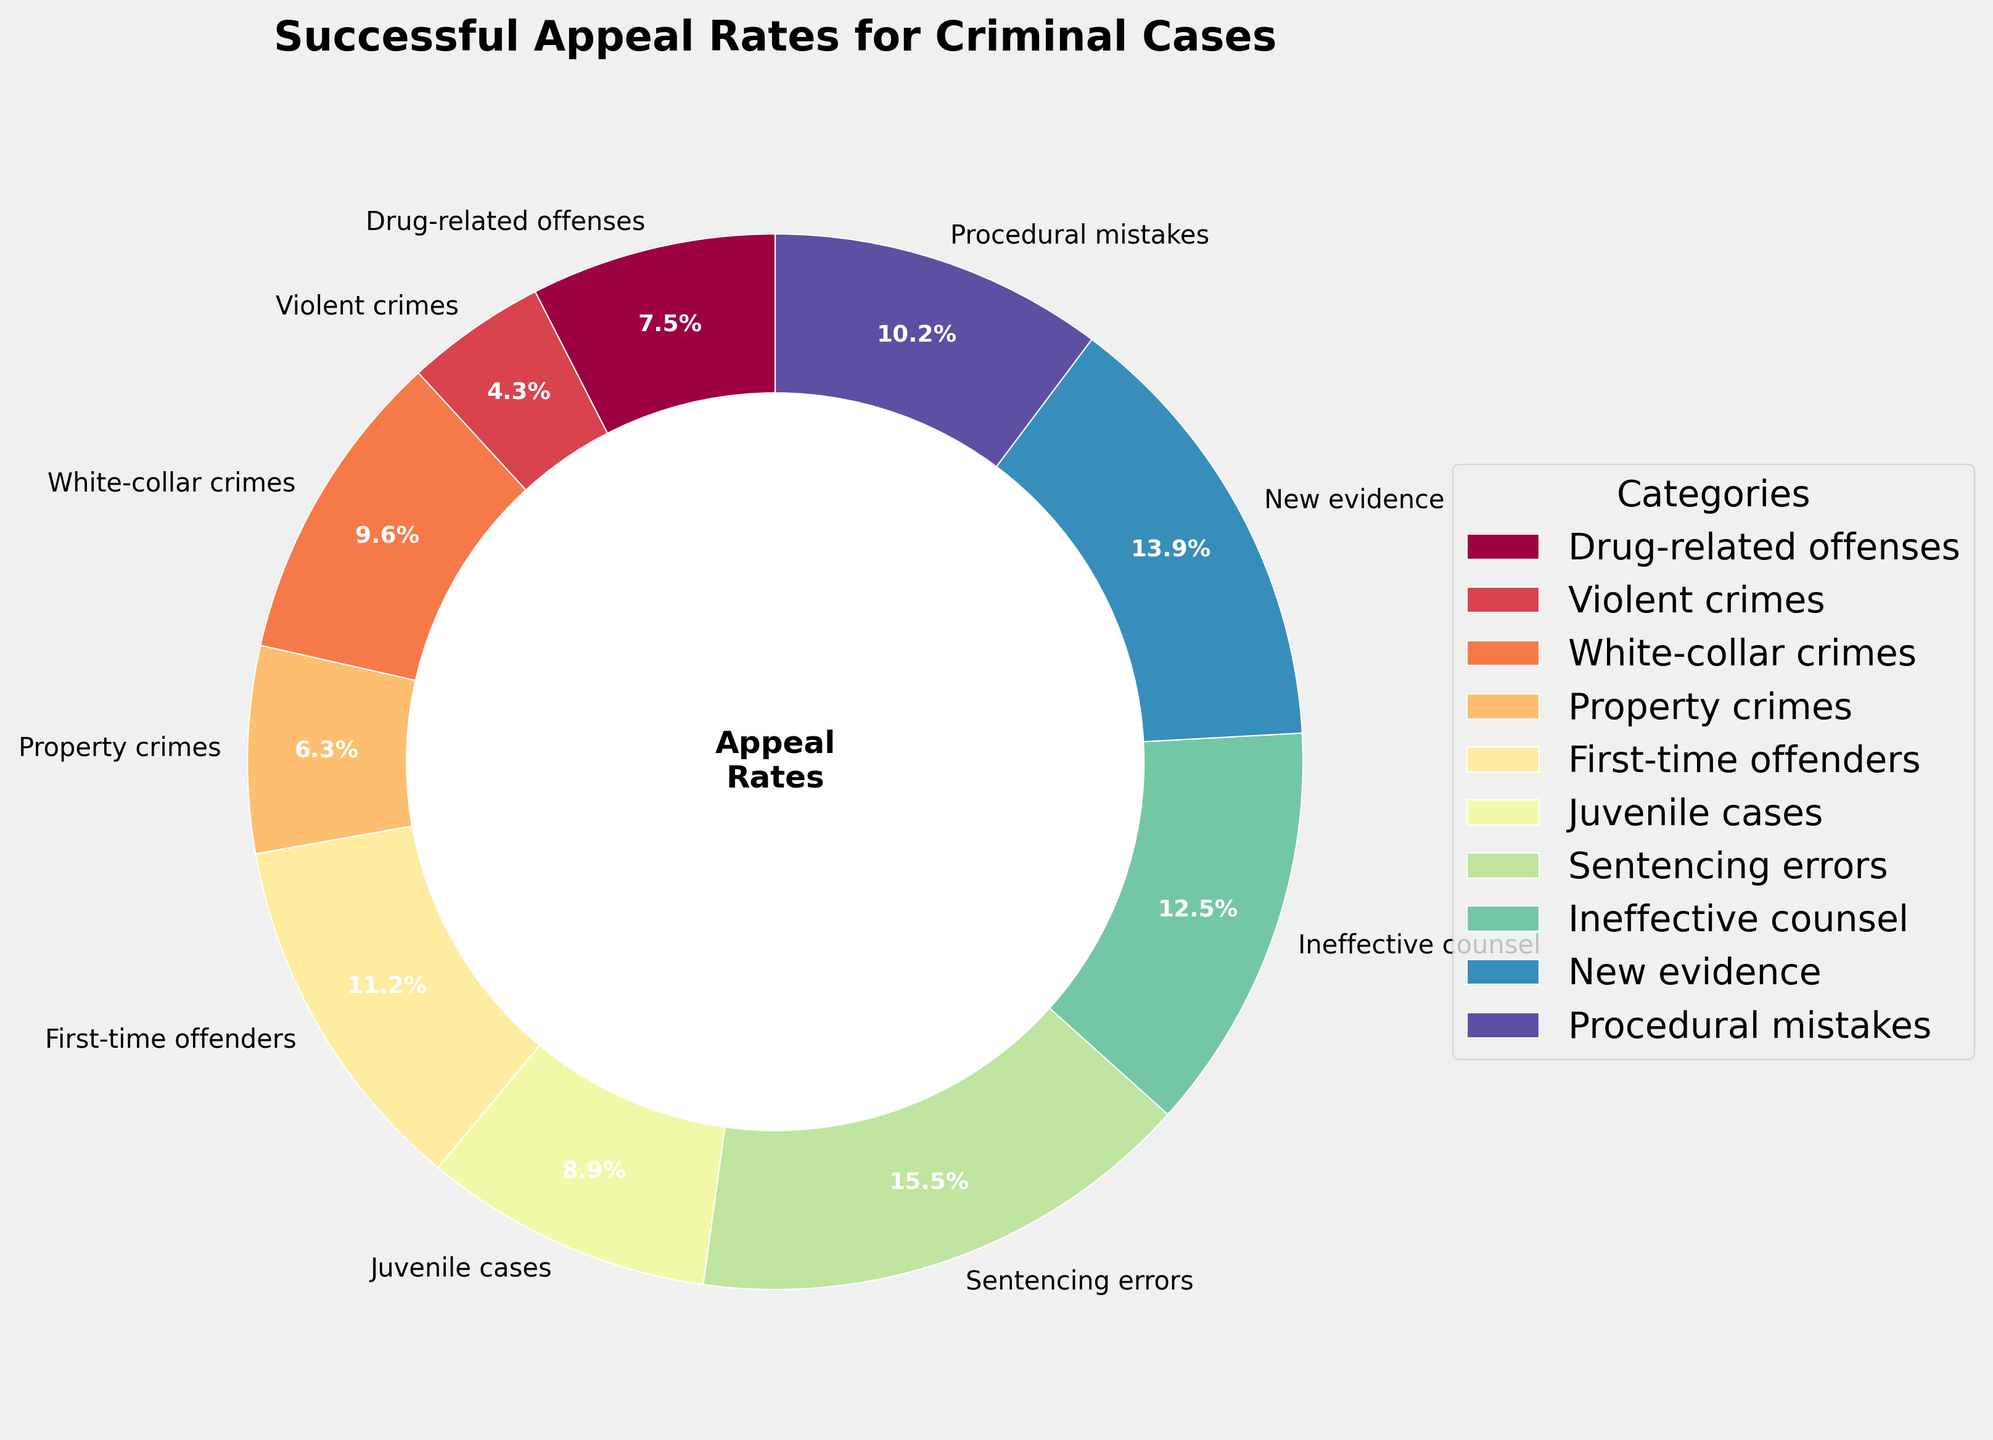Which category has the highest successful appeal rate? Identify the wedge with the highest percentage label. The "Sentencing errors" category has the highest successful appeal rate at 31.4%.
Answer: Sentencing errors Which category has the lowest successful appeal rate? Identify the wedge with the smallest percentage label. The "Violent crimes" category has the lowest successful appeal rate at 8.7%.
Answer: Violent crimes What is the combined successful appeal rate for "Ineffective counsel" and "New evidence"? Add the rates for "Ineffective counsel" (25.3%) and "New evidence" (28.1%). The combined rate is 25.3 + 28.1 = 53.4%.
Answer: 53.4% Is the successful appeal rate for "First-time offenders" higher than for "Juvenile cases"? Compare the rates for "First-time offenders" (22.6%) and "Juvenile cases" (17.9%). First-time offenders have a higher successful appeal rate.
Answer: Yes Which categories have a successful appeal rate greater than 20%? Identify the wedges with percentage labels greater than 20%. The categories are "First-time offenders" (22.6%), "Ineffective counsel" (25.3%), "New evidence" (28.1%), "Procedural mistakes" (20.7%), and "Sentencing errors" (31.4%).
Answer: First-time offenders, Ineffective counsel, New evidence, Procedural mistakes, Sentencing errors Is the combined successful appeal rate of "White-collar crimes" and "Property crimes" higher than that of "Drug-related offenses", "Violent crimes", and "Juvenile cases"? Calculate the combined rates: "White-collar crimes" (19.5%) + "Property crimes" (12.8%) = 32.3%. "Drug-related offenses" (15.2%) + "Violent crimes" (8.7%) + "Juvenile cases" (17.9%) = 41.8%. Compare 32.3% and 41.8%.
Answer: No Which category occupies the most significant visual representation in the pie chart? The wedge labeled with the highest percentage represents the "Sentencing errors" category at 31.4%.
Answer: Sentencing errors Which category has a successful appeal rate closest to the average rate of all categories? Calculate the average successful appeal rate: (15.2 + 8.7 + 19.5 + 12.8 + 22.6 + 17.9 + 31.4 + 25.3 + 28.1 + 20.7) / 10 = 20.22%. The closest rate is "Procedural mistakes" at 20.7%.
Answer: Procedural mistakes What percentage of the total do "Drug-related offenses" and "First-time offenders" make up? Add the rates for "Drug-related offenses" (15.2%) and "First-time offenders" (22.6%). The combined rate is 15.2 + 22.6 = 37.8%.
Answer: 37.8% Are there more categories with a successful appeal rate above or below 20%? Count the categories above 20%: First-time offenders, Ineffective counsel, New evidence, Procedural mistakes, Sentencing errors = 5. Below 20%: Drug-related offenses, Violent crimes, White-collar crimes, Property crimes, Juvenile cases = 5. The count is equal.
Answer: Equal 